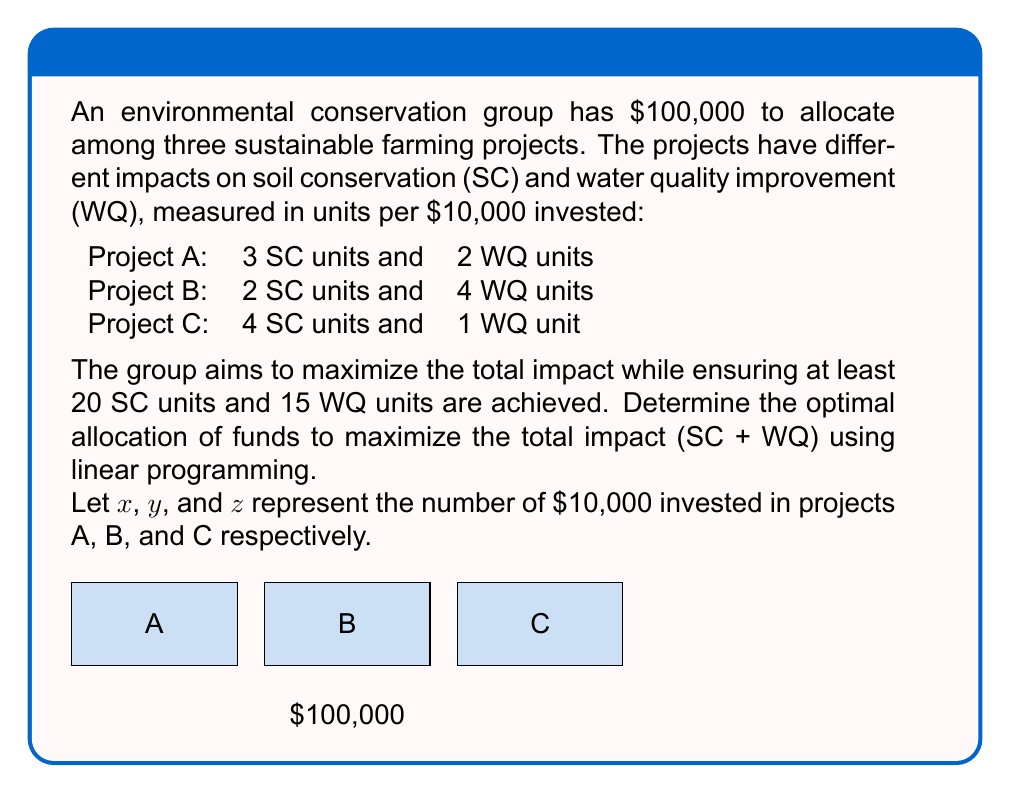Help me with this question. Let's solve this problem step-by-step using linear programming:

1) Define the objective function:
   Maximize $Z = (3x + 2y + 4z) + (2x + 4y + z)$ (Total SC + WQ units)
   Simplify: Maximize $Z = 5x + 6y + 5z$

2) Set up the constraints:
   a) Budget constraint: $x + y + z \leq 10$ (since each unit is $10,000)
   b) Soil Conservation constraint: $3x + 2y + 4z \geq 20$
   c) Water Quality constraint: $2x + 4y + z \geq 15$
   d) Non-negativity: $x, y, z \geq 0$

3) Solve using the simplex method or linear programming software. Here's the setup:

   Maximize: $Z = 5x + 6y + 5z$
   Subject to:
   $x + y + z \leq 10$
   $3x + 2y + 4z \geq 20$
   $2x + 4y + z \geq 15$
   $x, y, z \geq 0$

4) Solving this system yields the optimal solution:
   $x = 2.5$, $y = 3.75$, $z = 3.75$

5) Interpret the results:
   Project A: $25,000 (2.5 * $10,000)
   Project B: $37,500 (3.75 * $10,000)
   Project C: $37,500 (3.75 * $10,000)

6) Calculate the total impact:
   $Z = 5(2.5) + 6(3.75) + 5(3.75) = 12.5 + 22.5 + 18.75 = 53.75$ units

Therefore, the optimal allocation is $25,000 to Project A, $37,500 to Project B, and $37,500 to Project C, achieving a total impact of 53.75 units.
Answer: A: $25,000, B: $37,500, C: $37,500; Total impact: 53.75 units 